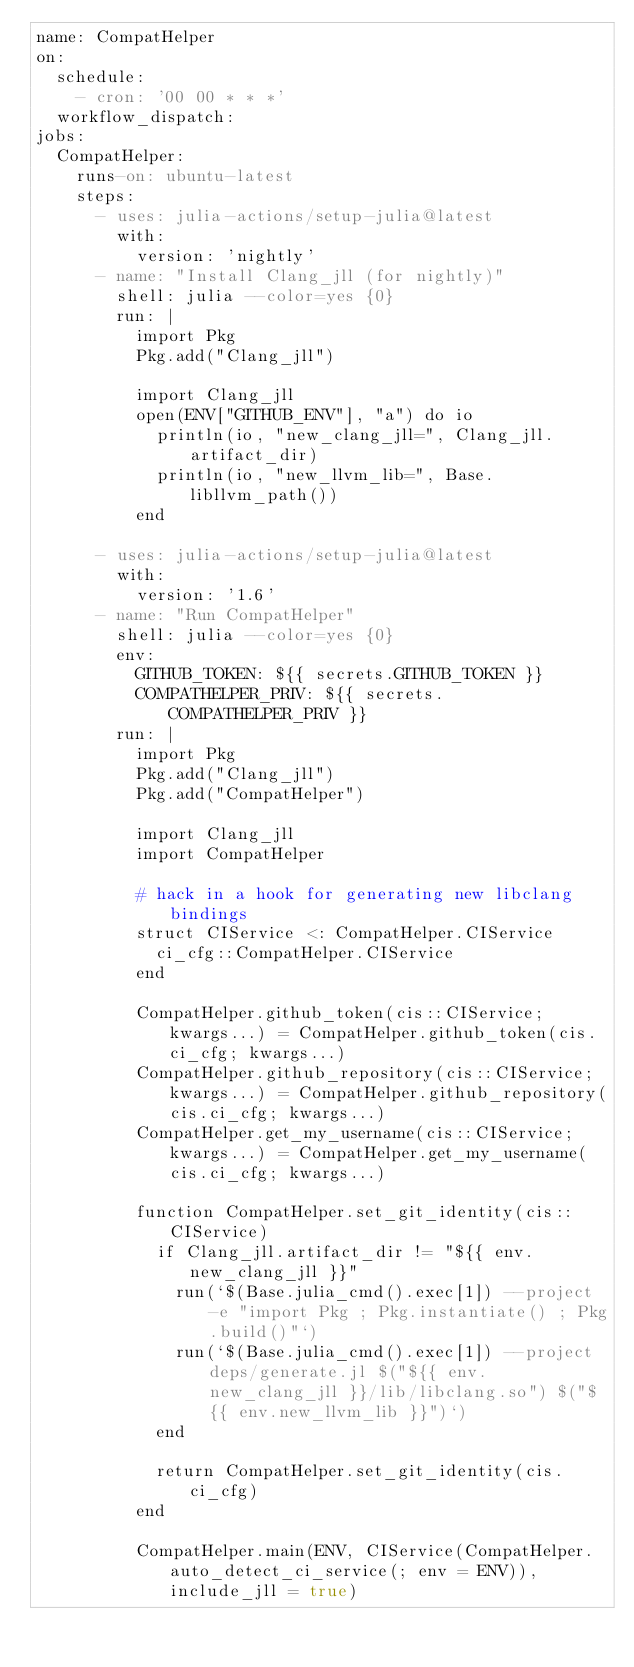<code> <loc_0><loc_0><loc_500><loc_500><_YAML_>name: CompatHelper
on:
  schedule:
    - cron: '00 00 * * *'
  workflow_dispatch:
jobs:
  CompatHelper:
    runs-on: ubuntu-latest
    steps:
      - uses: julia-actions/setup-julia@latest
        with:
          version: 'nightly'
      - name: "Install Clang_jll (for nightly)"
        shell: julia --color=yes {0}
        run: |
          import Pkg
          Pkg.add("Clang_jll")
          
          import Clang_jll
          open(ENV["GITHUB_ENV"], "a") do io
            println(io, "new_clang_jll=", Clang_jll.artifact_dir)
            println(io, "new_llvm_lib=", Base.libllvm_path())
          end
      
      - uses: julia-actions/setup-julia@latest
        with:
          version: '1.6'
      - name: "Run CompatHelper"
        shell: julia --color=yes {0}
        env:
          GITHUB_TOKEN: ${{ secrets.GITHUB_TOKEN }}
          COMPATHELPER_PRIV: ${{ secrets.COMPATHELPER_PRIV }}
        run: |
          import Pkg
          Pkg.add("Clang_jll")
          Pkg.add("CompatHelper")
          
          import Clang_jll
          import CompatHelper
          
          # hack in a hook for generating new libclang bindings
          struct CIService <: CompatHelper.CIService
            ci_cfg::CompatHelper.CIService
          end
          
          CompatHelper.github_token(cis::CIService; kwargs...) = CompatHelper.github_token(cis.ci_cfg; kwargs...)
          CompatHelper.github_repository(cis::CIService; kwargs...) = CompatHelper.github_repository(cis.ci_cfg; kwargs...)
          CompatHelper.get_my_username(cis::CIService; kwargs...) = CompatHelper.get_my_username(cis.ci_cfg; kwargs...)
          
          function CompatHelper.set_git_identity(cis::CIService)
            if Clang_jll.artifact_dir != "${{ env.new_clang_jll }}"
              run(`$(Base.julia_cmd().exec[1]) --project -e "import Pkg ; Pkg.instantiate() ; Pkg.build()"`)
              run(`$(Base.julia_cmd().exec[1]) --project deps/generate.jl $("${{ env.new_clang_jll }}/lib/libclang.so") $("${{ env.new_llvm_lib }}")`)
            end
            
            return CompatHelper.set_git_identity(cis.ci_cfg)
          end
          
          CompatHelper.main(ENV, CIService(CompatHelper.auto_detect_ci_service(; env = ENV)), include_jll = true)
</code> 